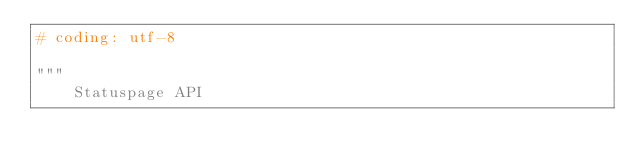<code> <loc_0><loc_0><loc_500><loc_500><_Python_># coding: utf-8

"""
    Statuspage API
</code> 